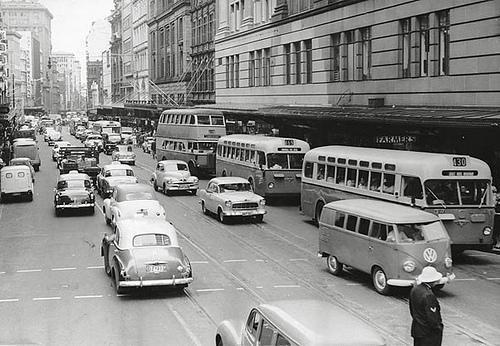How many vans do you see?
Give a very brief answer. 1. How many buses are visible?
Give a very brief answer. 4. How many cars are in the picture?
Give a very brief answer. 4. 